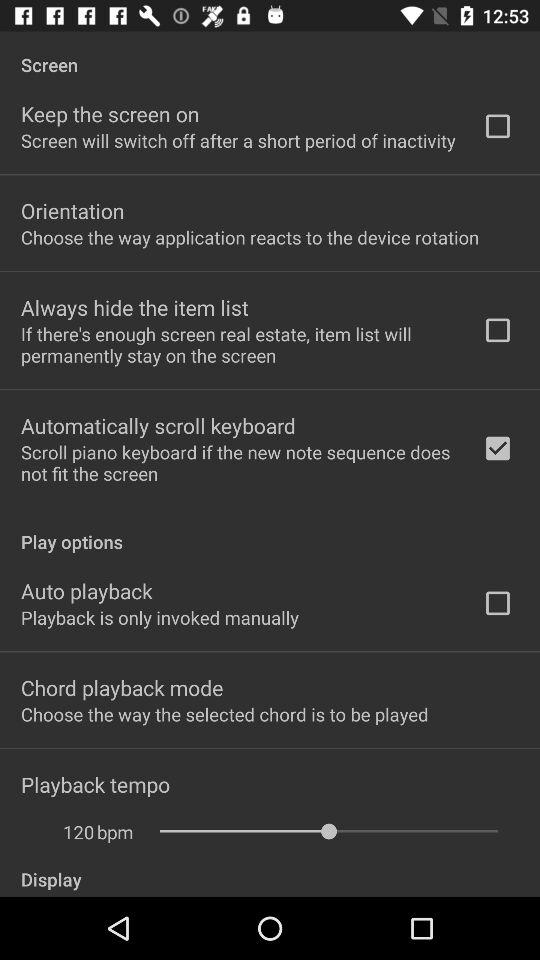Which option is checked? The checked option is "Automatically scroll keyboard". 